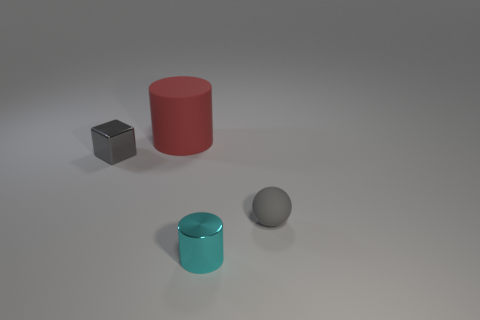Add 2 red cylinders. How many objects exist? 6 Subtract all balls. How many objects are left? 3 Add 1 tiny metallic blocks. How many tiny metallic blocks are left? 2 Add 2 blue metal cylinders. How many blue metal cylinders exist? 2 Subtract 0 gray cylinders. How many objects are left? 4 Subtract all spheres. Subtract all big red cylinders. How many objects are left? 2 